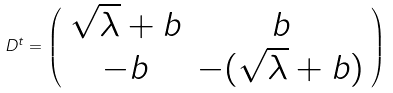<formula> <loc_0><loc_0><loc_500><loc_500>D ^ { t } = \left ( \begin{array} { c c } \sqrt { \lambda } + b & b \\ - b & - ( \sqrt { \lambda } + b ) \end{array} \right )</formula> 